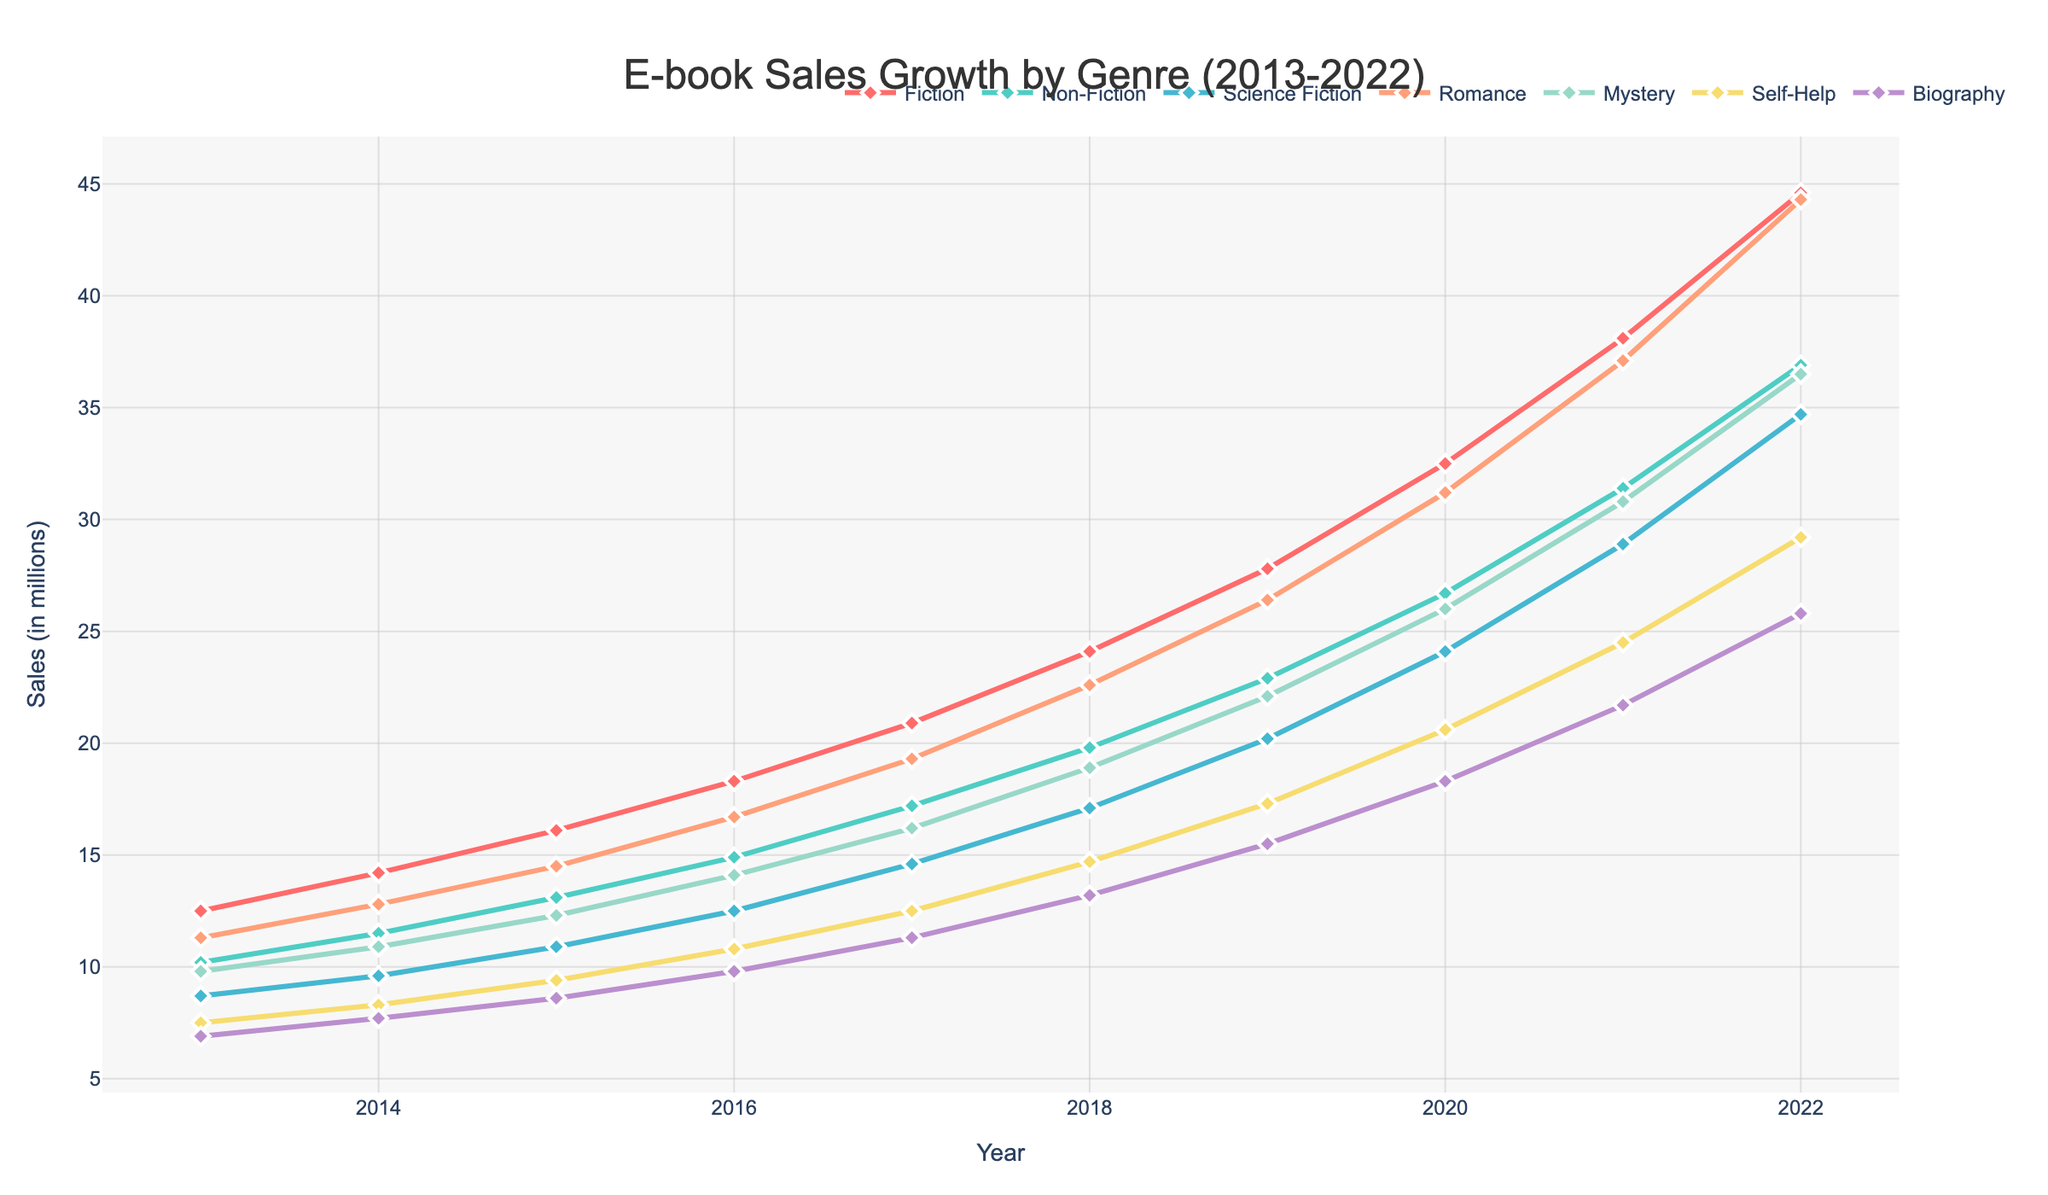What is the overall trend for Fiction e-book sales from 2013 to 2022? The Fiction e-book sales show a consistent upward trend. From 12.5 million in 2013, sales increased each year, reaching 44.6 million in 2022. The growth is steady and significant over the decade.
Answer: Upward trend Which genre had the highest sales in 2022? In 2022, the genre with the highest sales is Fiction, with 44.6 million sales. This is evident as the Fiction line peaks higher than any other genre at the end of the timeline in the figure.
Answer: Fiction By how much did Non-Fiction e-book sales increase from 2013 to 2022? Non-Fiction sales increased from 10.2 million in 2013 to 36.9 million in 2022. The increase is calculated as 36.9 - 10.2 = 26.7 million.
Answer: 26.7 million Which genre saw the most significant increase in sales between 2016 and 2020? To find the most significant increase, we look at the difference in sales for each genre from 2016 to 2020. Fiction increased from 18.3 to 32.5 (=14.2), Non-Fiction from 14.9 to 26.7 (=11.8), Science Fiction from 12.5 to 24.1 (=11.6), Romance from 16.7 to 31.2 (=14.5), Mystery from 14.1 to 26.0 (=11.9), Self-Help from 10.8 to 20.6 (=9.8), and Biography from 9.8 to 18.3 (=8.5). The genre with the highest increase is Romance, with an increase of 14.5 million.
Answer: Romance What is the average sales growth per year for the Science Fiction genre from 2013 to 2022? The sales for Science Fiction began at 8.7 million in 2013 and reached 34.7 million in 2022. The total growth over the 9-year period (2022-2013) is 34.7 - 8.7 = 26 million. Dividing by 9 years gives an average annual growth of 26 / 9 ≈ 2.89 million per year.
Answer: 2.89 million per year Which genre had the slowest growth rate during the entire period? To find the slowest growth rate, calculate the total increase for each genre and divide by 9 years. Fiction: (44.6-12.5)/9, Non-Fiction: (36.9-10.2)/9, Science Fiction: (34.7-8.7)/9, Romance: (44.3-11.3)/9, Mystery: (36.5-9.8)/9, Self-Help: (29.2-7.5)/9, Biography: (25.8-6.9)/9. Calculating these we find: Fiction ≈3.57, Non-Fiction ≈2.97, Science Fiction ≈2.89, Romance ≈3.67, Mystery ≈2.97, Self-Help ≈2.41, Biography ≈2.1. The slowest growth rate is Biography with 2.1 million per year.
Answer: Biography 